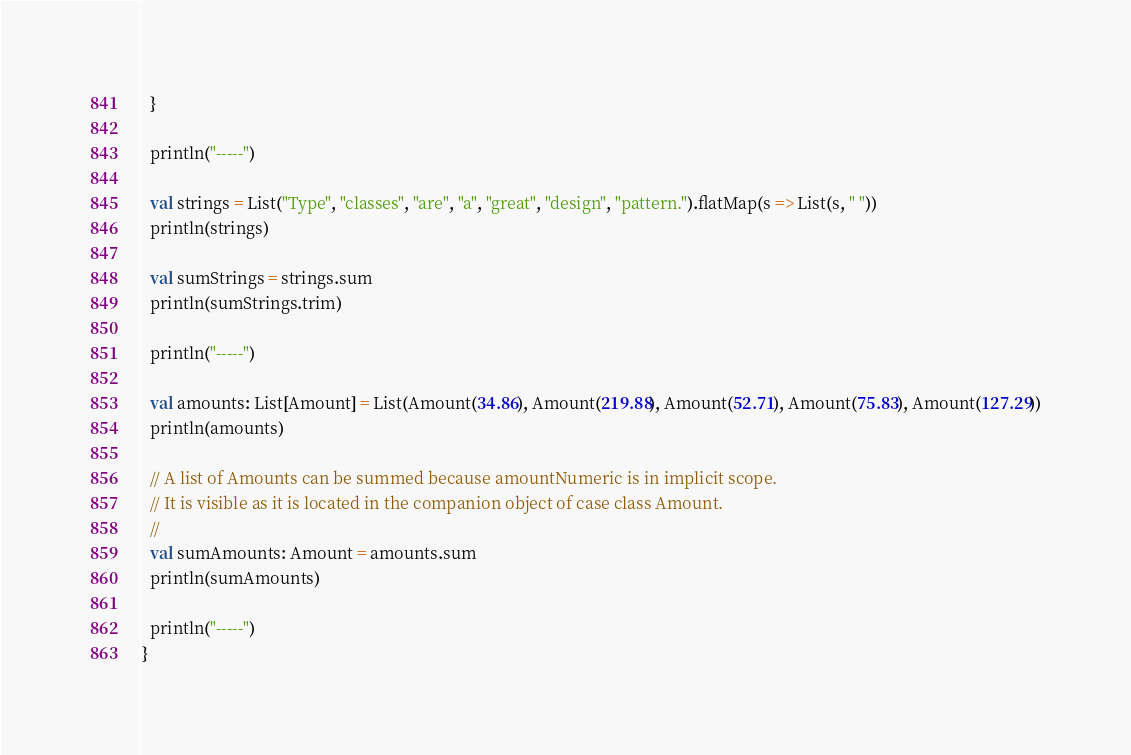Convert code to text. <code><loc_0><loc_0><loc_500><loc_500><_Scala_>  }

  println("-----")

  val strings = List("Type", "classes", "are", "a", "great", "design", "pattern.").flatMap(s => List(s, " "))
  println(strings)

  val sumStrings = strings.sum
  println(sumStrings.trim)

  println("-----")

  val amounts: List[Amount] = List(Amount(34.86), Amount(219.88), Amount(52.71), Amount(75.83), Amount(127.29))
  println(amounts)

  // A list of Amounts can be summed because amountNumeric is in implicit scope.
  // It is visible as it is located in the companion object of case class Amount.
  //
  val sumAmounts: Amount = amounts.sum
  println(sumAmounts)

  println("-----")
}
</code> 